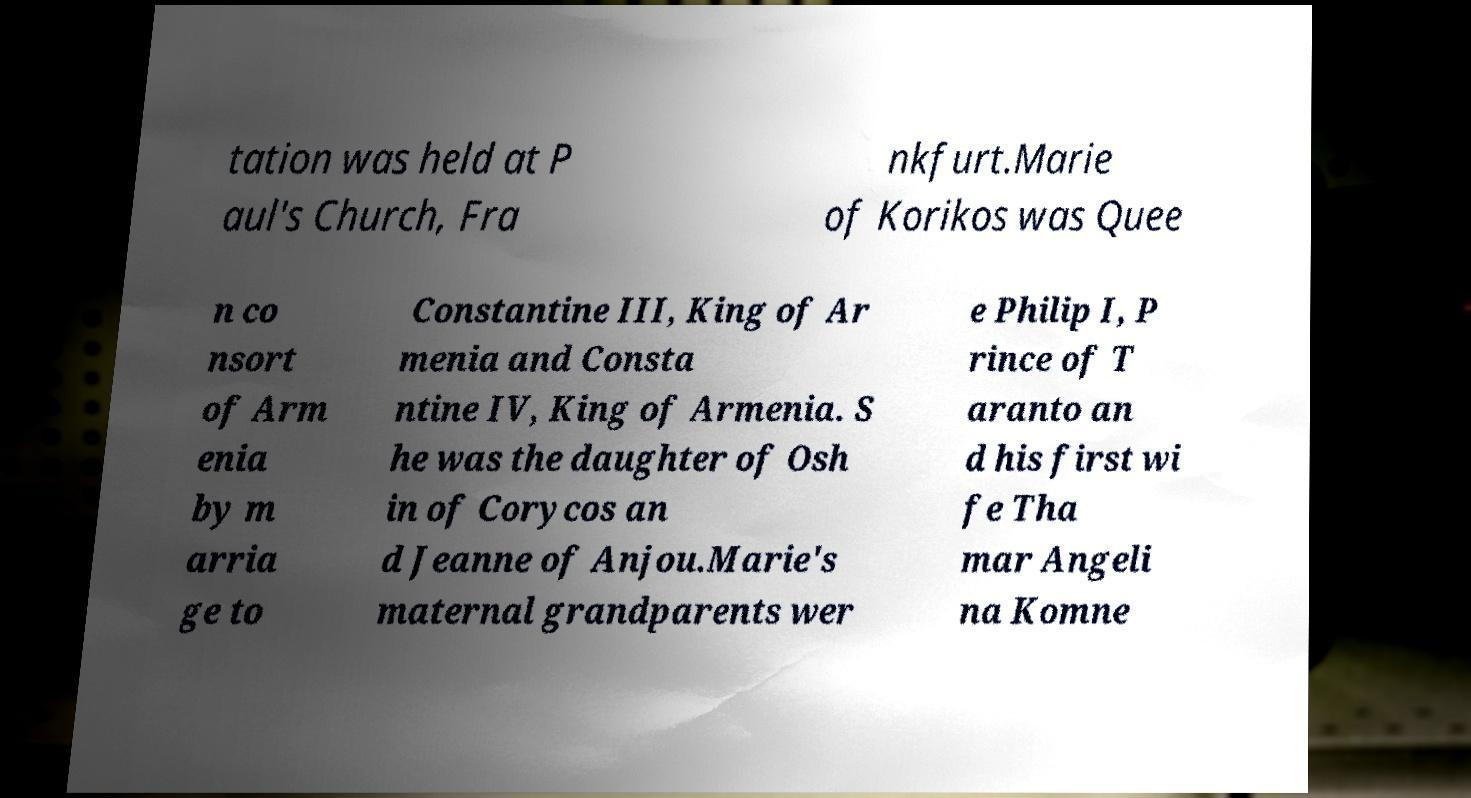Please identify and transcribe the text found in this image. tation was held at P aul's Church, Fra nkfurt.Marie of Korikos was Quee n co nsort of Arm enia by m arria ge to Constantine III, King of Ar menia and Consta ntine IV, King of Armenia. S he was the daughter of Osh in of Corycos an d Jeanne of Anjou.Marie's maternal grandparents wer e Philip I, P rince of T aranto an d his first wi fe Tha mar Angeli na Komne 